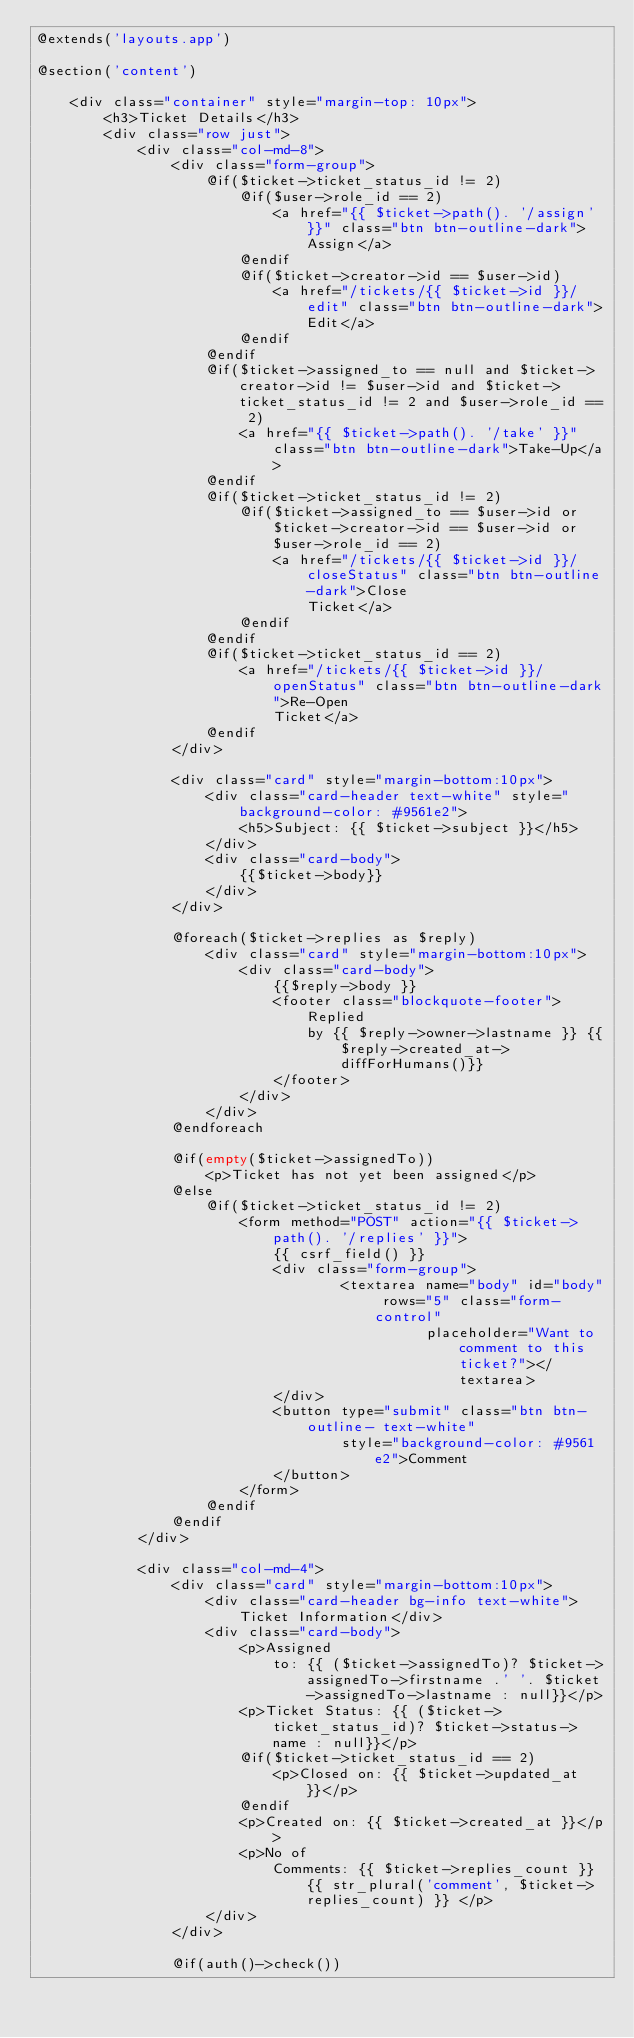<code> <loc_0><loc_0><loc_500><loc_500><_PHP_>@extends('layouts.app')

@section('content')

    <div class="container" style="margin-top: 10px">
        <h3>Ticket Details</h3>
        <div class="row just">
            <div class="col-md-8">
                <div class="form-group">
                    @if($ticket->ticket_status_id != 2)
                        @if($user->role_id == 2)
                            <a href="{{ $ticket->path(). '/assign' }}" class="btn btn-outline-dark">Assign</a>
                        @endif
                        @if($ticket->creator->id == $user->id)
                            <a href="/tickets/{{ $ticket->id }}/edit" class="btn btn-outline-dark">Edit</a>
                        @endif
                    @endif
                    @if($ticket->assigned_to == null and $ticket->creator->id != $user->id and $ticket->ticket_status_id != 2 and $user->role_id == 2)
                        <a href="{{ $ticket->path(). '/take' }}" class="btn btn-outline-dark">Take-Up</a>
                    @endif
                    @if($ticket->ticket_status_id != 2)
                        @if($ticket->assigned_to == $user->id or $ticket->creator->id == $user->id or $user->role_id == 2)
                            <a href="/tickets/{{ $ticket->id }}/closeStatus" class="btn btn-outline-dark">Close
                                Ticket</a>
                        @endif
                    @endif
                    @if($ticket->ticket_status_id == 2)
                        <a href="/tickets/{{ $ticket->id }}/openStatus" class="btn btn-outline-dark">Re-Open
                            Ticket</a>
                    @endif
                </div>

                <div class="card" style="margin-bottom:10px">
                    <div class="card-header text-white" style="background-color: #9561e2">
                        <h5>Subject: {{ $ticket->subject }}</h5>
                    </div>
                    <div class="card-body">
                        {{$ticket->body}}
                    </div>
                </div>

                @foreach($ticket->replies as $reply)
                    <div class="card" style="margin-bottom:10px">
                        <div class="card-body">
                            {{$reply->body }}
                            <footer class="blockquote-footer">Replied
                                by {{ $reply->owner->lastname }} {{$reply->created_at->diffForHumans()}}
                            </footer>
                        </div>
                    </div>
                @endforeach

                @if(empty($ticket->assignedTo))
                    <p>Ticket has not yet been assigned</p>
                @else
                    @if($ticket->ticket_status_id != 2)
                        <form method="POST" action="{{ $ticket->path(). '/replies' }}">
                            {{ csrf_field() }}
                            <div class="form-group">
                                    <textarea name="body" id="body" rows="5" class="form-control"
                                              placeholder="Want to comment to this ticket?"></textarea>
                            </div>
                            <button type="submit" class="btn btn-outline- text-white"
                                    style="background-color: #9561e2">Comment
                            </button>
                        </form>
                    @endif
                @endif
            </div>

            <div class="col-md-4">
                <div class="card" style="margin-bottom:10px">
                    <div class="card-header bg-info text-white">Ticket Information</div>
                    <div class="card-body">
                        <p>Assigned
                            to: {{ ($ticket->assignedTo)? $ticket->assignedTo->firstname .' '. $ticket->assignedTo->lastname : null}}</p>
                        <p>Ticket Status: {{ ($ticket->ticket_status_id)? $ticket->status->name : null}}</p>
                        @if($ticket->ticket_status_id == 2)
                            <p>Closed on: {{ $ticket->updated_at}}</p>
                        @endif
                        <p>Created on: {{ $ticket->created_at }}</p>
                        <p>No of
                            Comments: {{ $ticket->replies_count }} {{ str_plural('comment', $ticket->replies_count) }} </p>
                    </div>
                </div>

                @if(auth()->check())</code> 